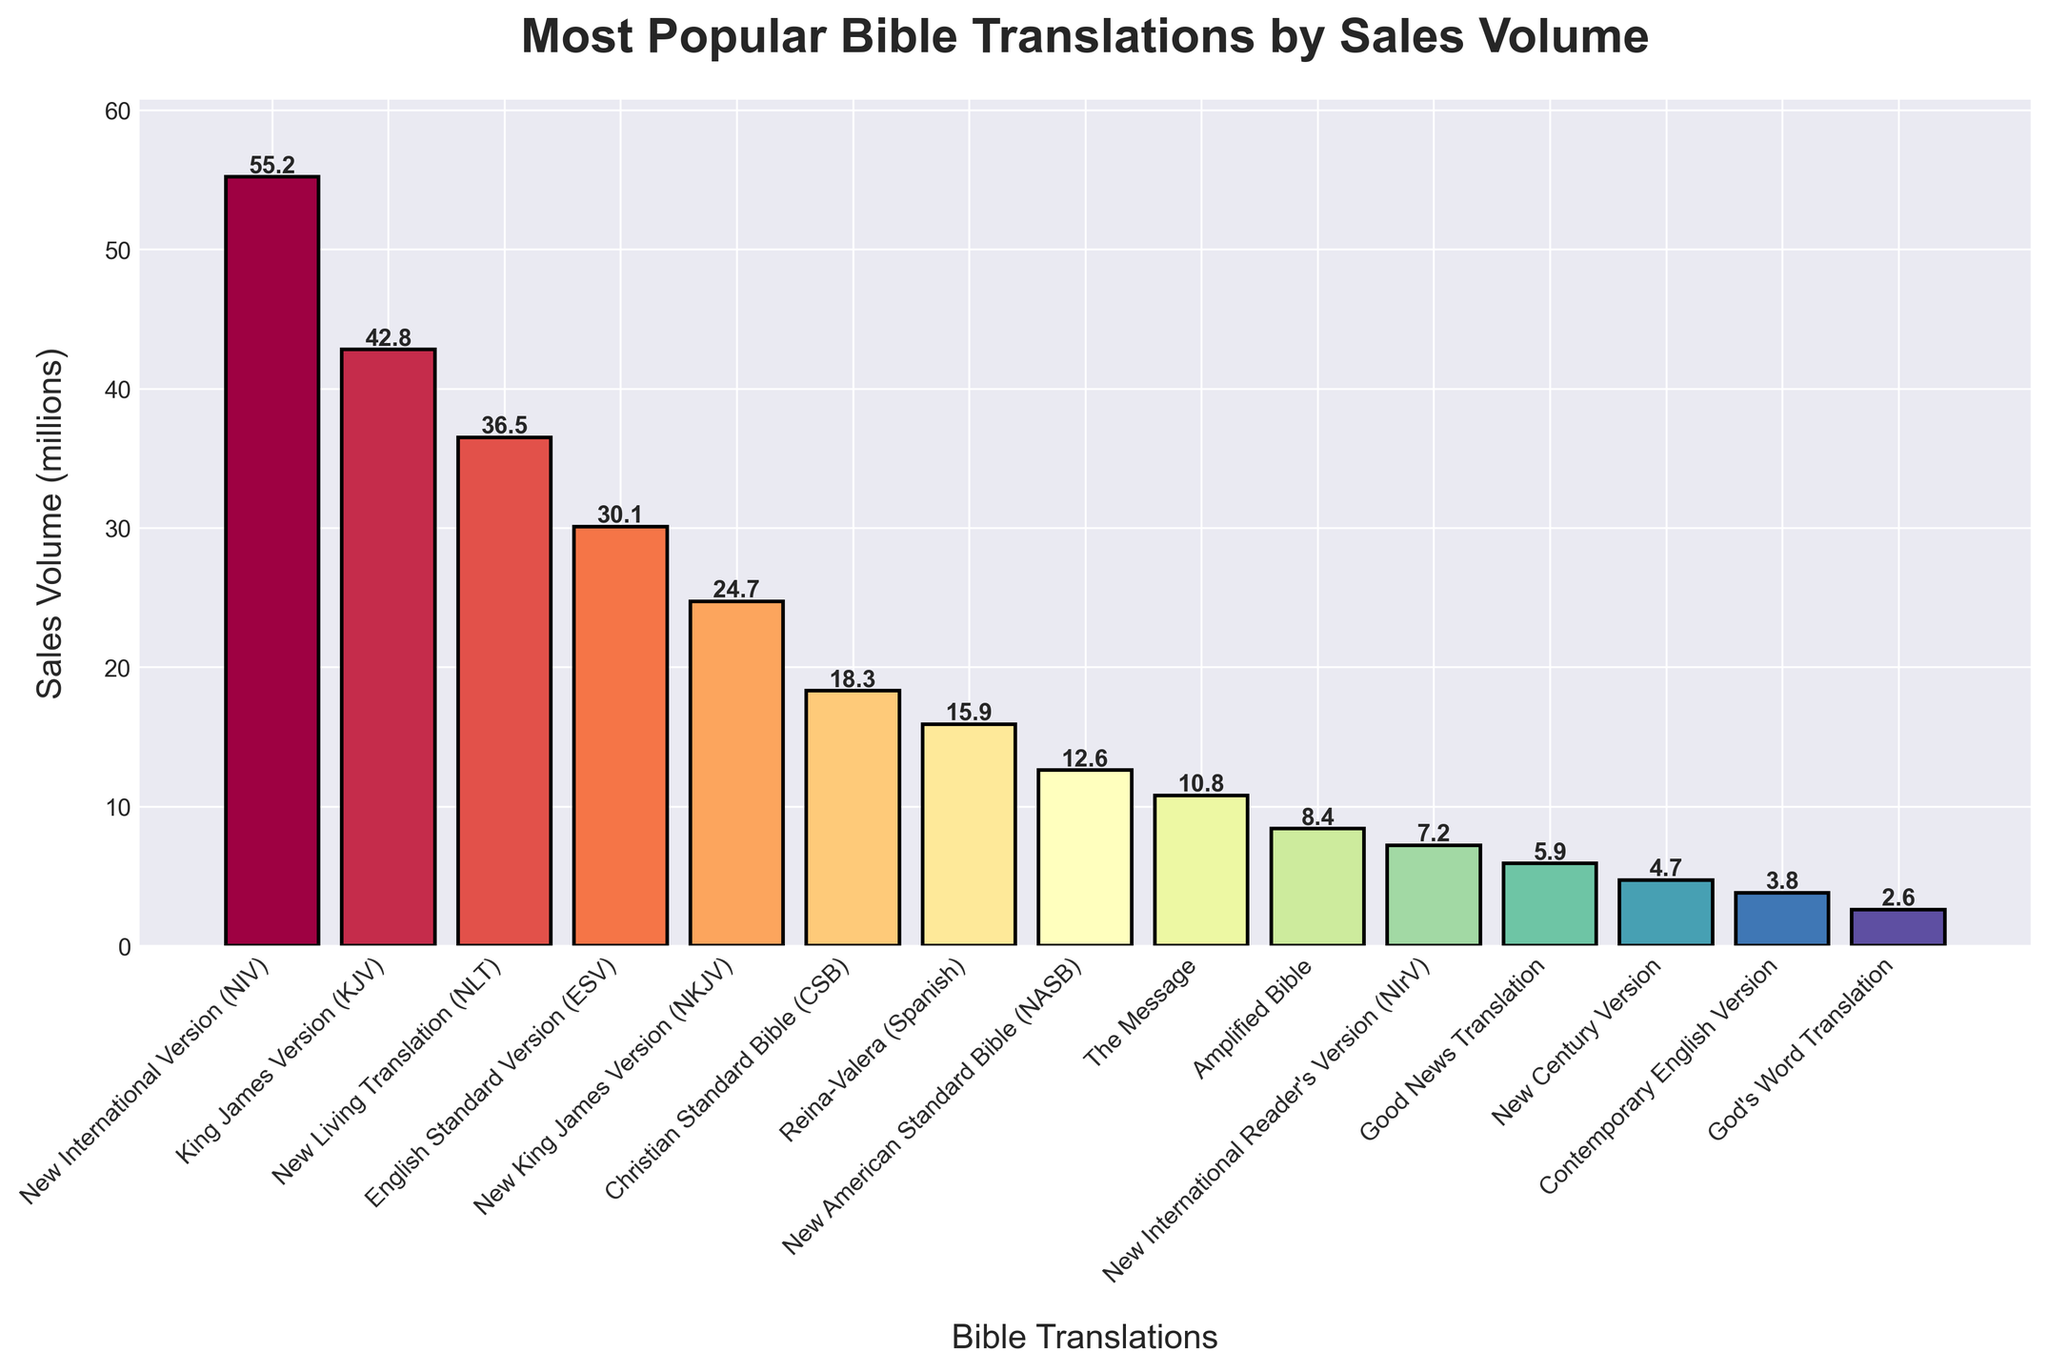Which Bible translation had the highest sales volume in the past decade? The Bible translation with the highest sales volume is listed at the top of the chart, indicated by the longest bar. This is the New International Version (NIV).
Answer: New International Version (NIV) How much higher are the sales of the King James Version (KJV) compared to the New Living Translation (NLT)? The chart shows the sales volume for KJV and NLT. Subtract the sales volume of NLT (36.5 million) from that of KJV (42.8 million).
Answer: 6.3 million What is the total sales volume of the top three Bible translations? Sum the sales volumes of the top three translations: NIV (55.2 million), KJV (42.8 million), and NLT (36.5 million). The total is 55.2 + 42.8 + 36.5 = 134.5 million.
Answer: 134.5 million Which Bible translation has slightly more than double the sales volume of the New American Standard Bible (NASB)? First, find the NASB sales volume, which is 12.6 million. Double this is 25.2 million. The closest value higher than this is the New King James Version (NKJV) at 24.7 million.
Answer: New King James Version (NKJV) How do the sales volumes of the English Standard Version (ESV) and the New International Reader's Version (NIrV) compare? Locate the bars for ESV and NIrV. ESV has a sales volume of 30.1 million, while NIrV has 7.2 million. ESV has substantially higher sales.
Answer: ESV has higher sales What is the combined sales volume of the Christian Standard Bible (CSB) and the Reina-Valera (Spanish) Bible translations? Sum the sales volumes of CSB (18.3 million) and Reina-Valera (15.9 million): 18.3 + 15.9 = 34.2 million.
Answer: 34.2 million Which Bible translation's sales volume is indicated by a bar that appears to be one of the shortest in the chart, and what is its value? Identify one of the shortest bars in the chart, which belong to the God's Word Translation with a sales volume of 2.6 million.
Answer: God's Word Translation, 2.6 million How does the sales volume of The Message compare to that of the Amplified Bible? The chart shows that The Message has a sales volume of 10.8 million, whereas the Amplified Bible has 8.4 million. The Message has higher sales.
Answer: The Message has higher sales What is the difference in sales volume between the English Standard Version (ESV) and the New American Standard Bible (NASB)? The sales volume of ESV is 30.1 million and that of NASB is 12.6 million. Subtract NASB's sales from ESV's: 30.1 - 12.6 = 17.5 million.
Answer: 17.5 million 